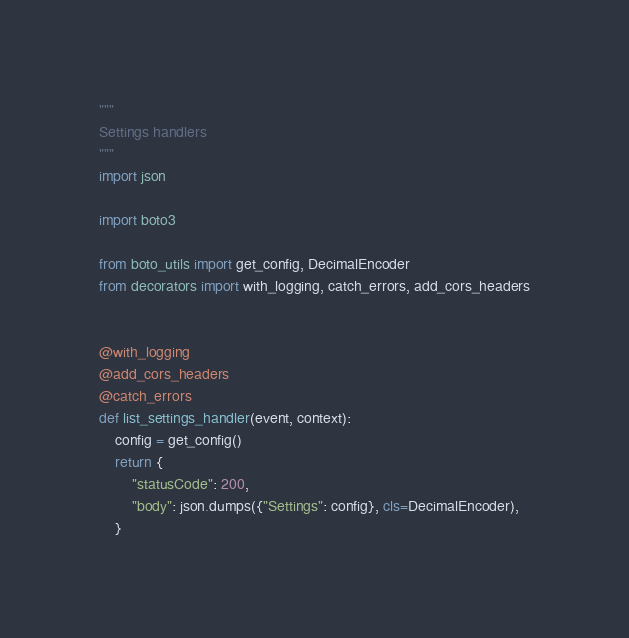<code> <loc_0><loc_0><loc_500><loc_500><_Python_>"""
Settings handlers
"""
import json

import boto3

from boto_utils import get_config, DecimalEncoder
from decorators import with_logging, catch_errors, add_cors_headers


@with_logging
@add_cors_headers
@catch_errors
def list_settings_handler(event, context):
    config = get_config()
    return {
        "statusCode": 200,
        "body": json.dumps({"Settings": config}, cls=DecimalEncoder),
    }
</code> 